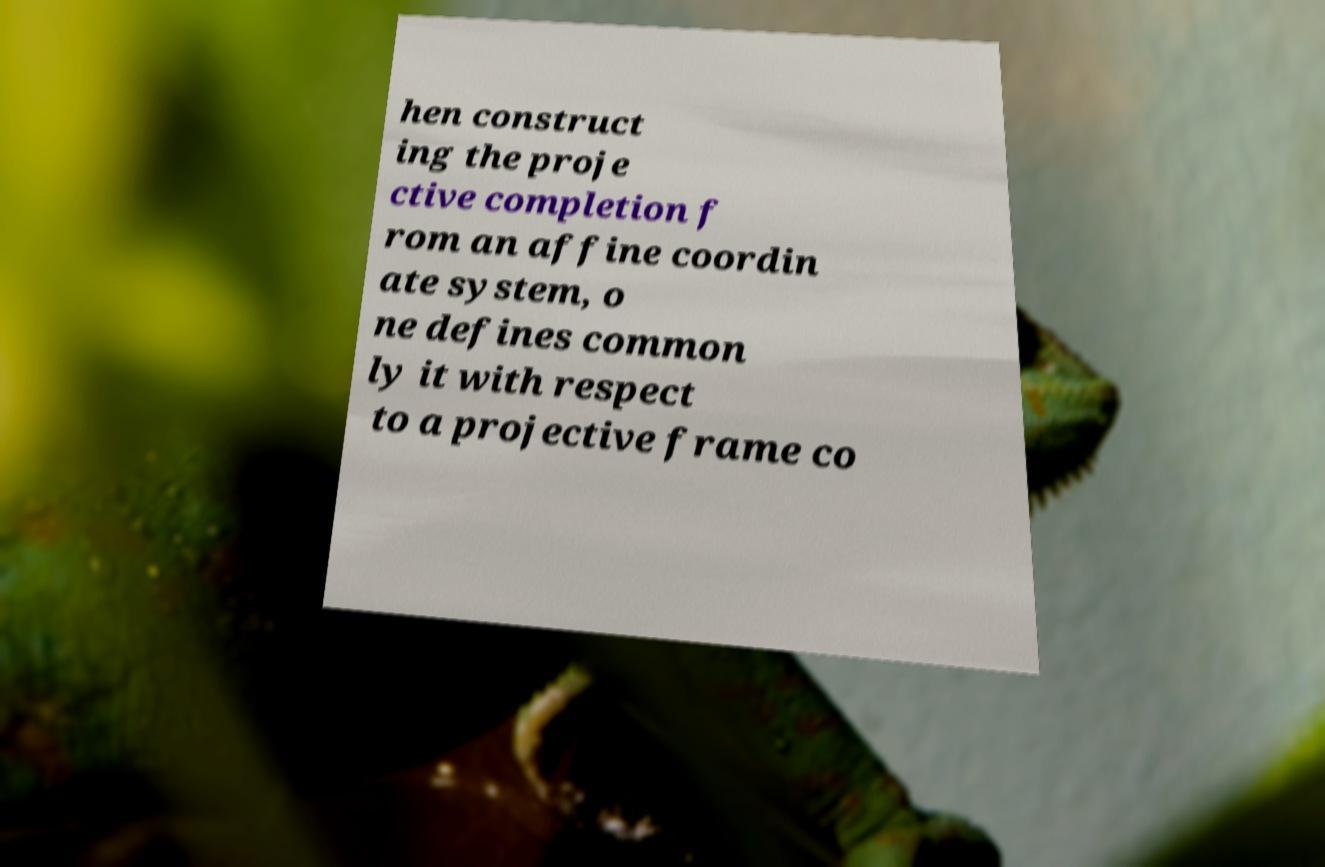Could you extract and type out the text from this image? hen construct ing the proje ctive completion f rom an affine coordin ate system, o ne defines common ly it with respect to a projective frame co 